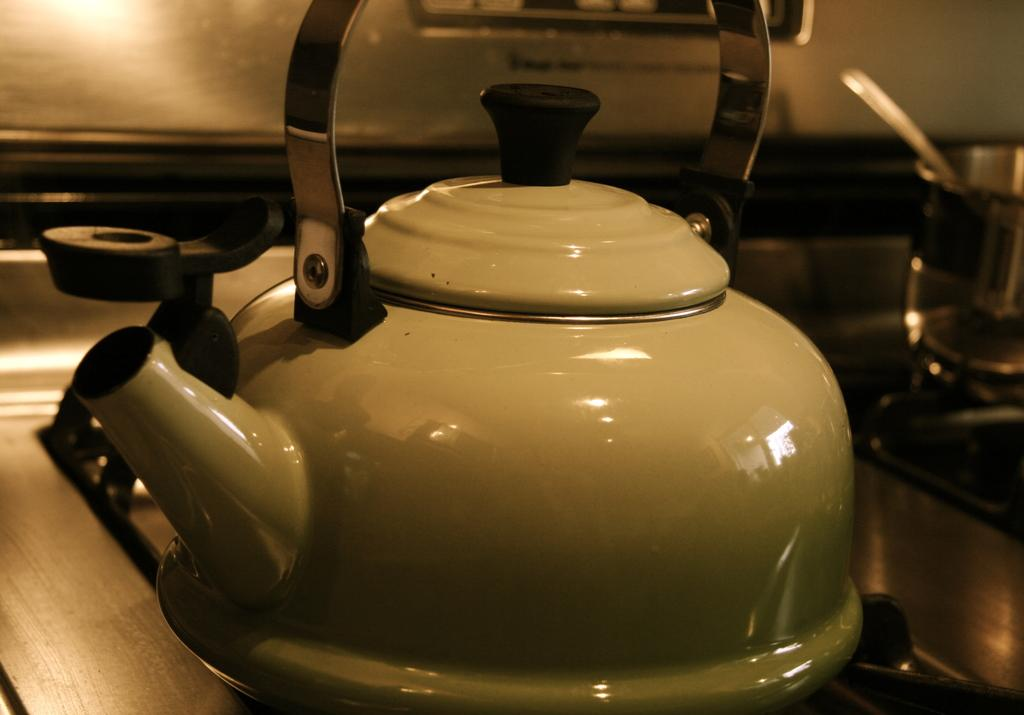What appliance is visible in the image? There is a coffee maker in the image. Where is the coffee maker located? The coffee maker is on a table. What else can be seen in the background of the image? There is a vessel and a spoon on the stove in the background of the image. How many people are participating in the protest in the image? There is no protest present in the image. What type of apparatus is used to measure the temperature of the coffee in the image? There is no apparatus visible in the image for measuring the temperature of the coffee. 